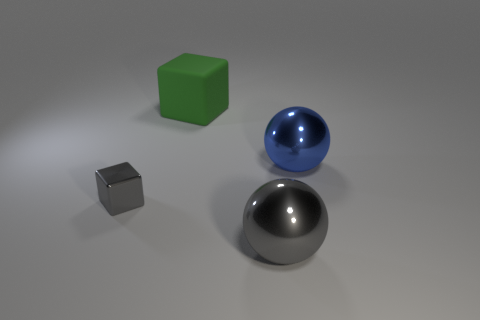There is a block that is the same size as the blue metallic ball; what material is it?
Offer a very short reply. Rubber. Is there a big green cube made of the same material as the large gray ball?
Offer a terse response. No. What is the color of the thing that is to the left of the block that is behind the metallic object that is on the left side of the rubber block?
Give a very brief answer. Gray. Is the color of the metallic sphere right of the gray ball the same as the big sphere in front of the small block?
Your answer should be very brief. No. Is there any other thing that is the same color as the rubber block?
Offer a very short reply. No. Is the number of large blue shiny spheres on the left side of the gray metallic ball less than the number of gray metallic blocks?
Ensure brevity in your answer.  Yes. What number of metallic blocks are there?
Offer a very short reply. 1. There is a tiny object; is it the same shape as the big shiny object that is in front of the small gray thing?
Give a very brief answer. No. Are there fewer large green rubber blocks that are in front of the large blue shiny sphere than big green objects left of the gray metallic cube?
Your response must be concise. No. Is there anything else that has the same shape as the blue thing?
Provide a short and direct response. Yes. 